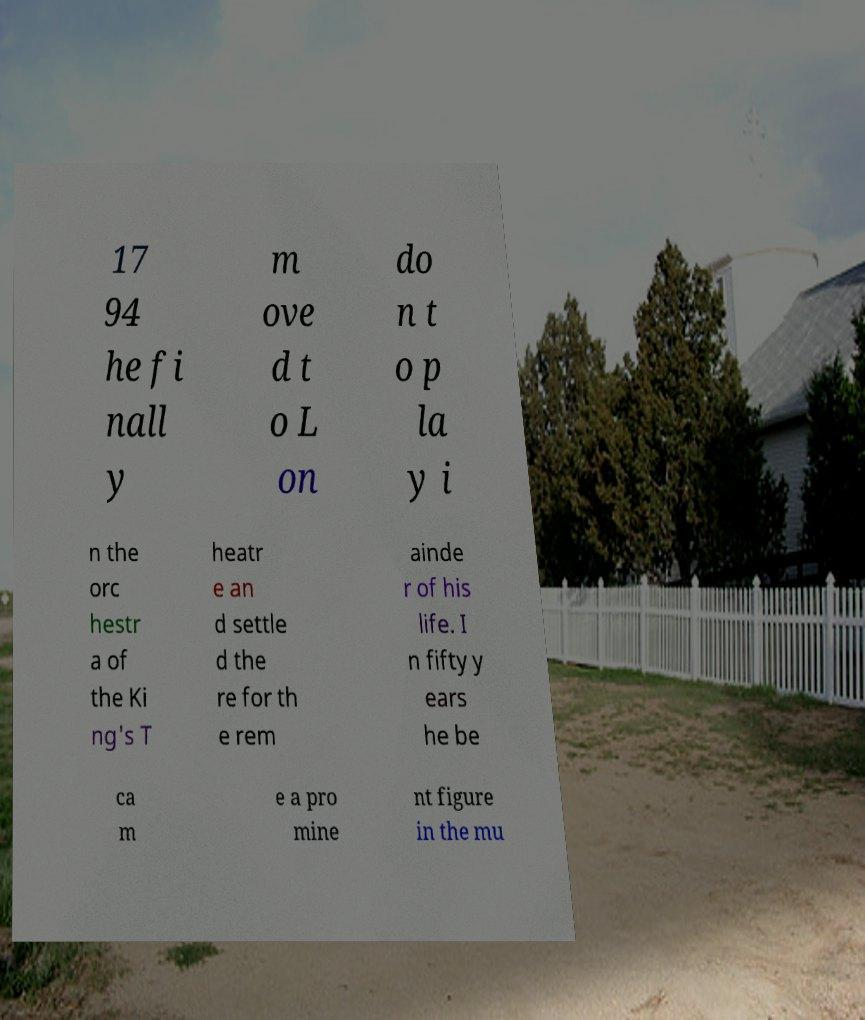There's text embedded in this image that I need extracted. Can you transcribe it verbatim? 17 94 he fi nall y m ove d t o L on do n t o p la y i n the orc hestr a of the Ki ng's T heatr e an d settle d the re for th e rem ainde r of his life. I n fifty y ears he be ca m e a pro mine nt figure in the mu 